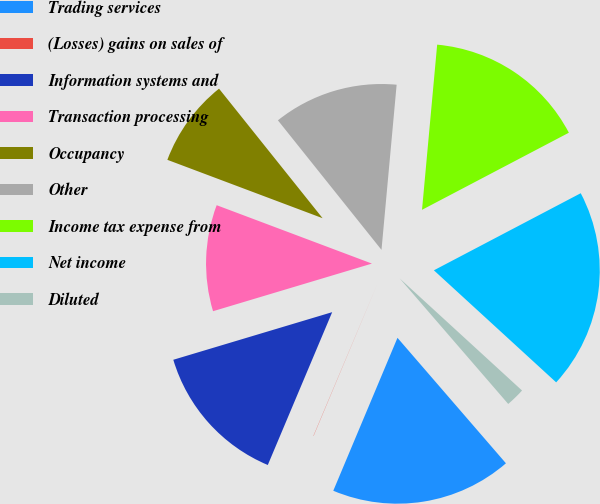<chart> <loc_0><loc_0><loc_500><loc_500><pie_chart><fcel>Trading services<fcel>(Losses) gains on sales of<fcel>Information systems and<fcel>Transaction processing<fcel>Occupancy<fcel>Other<fcel>Income tax expense from<fcel>Net income<fcel>Diluted<nl><fcel>17.67%<fcel>0.02%<fcel>14.02%<fcel>10.36%<fcel>8.54%<fcel>12.19%<fcel>15.85%<fcel>19.5%<fcel>1.85%<nl></chart> 